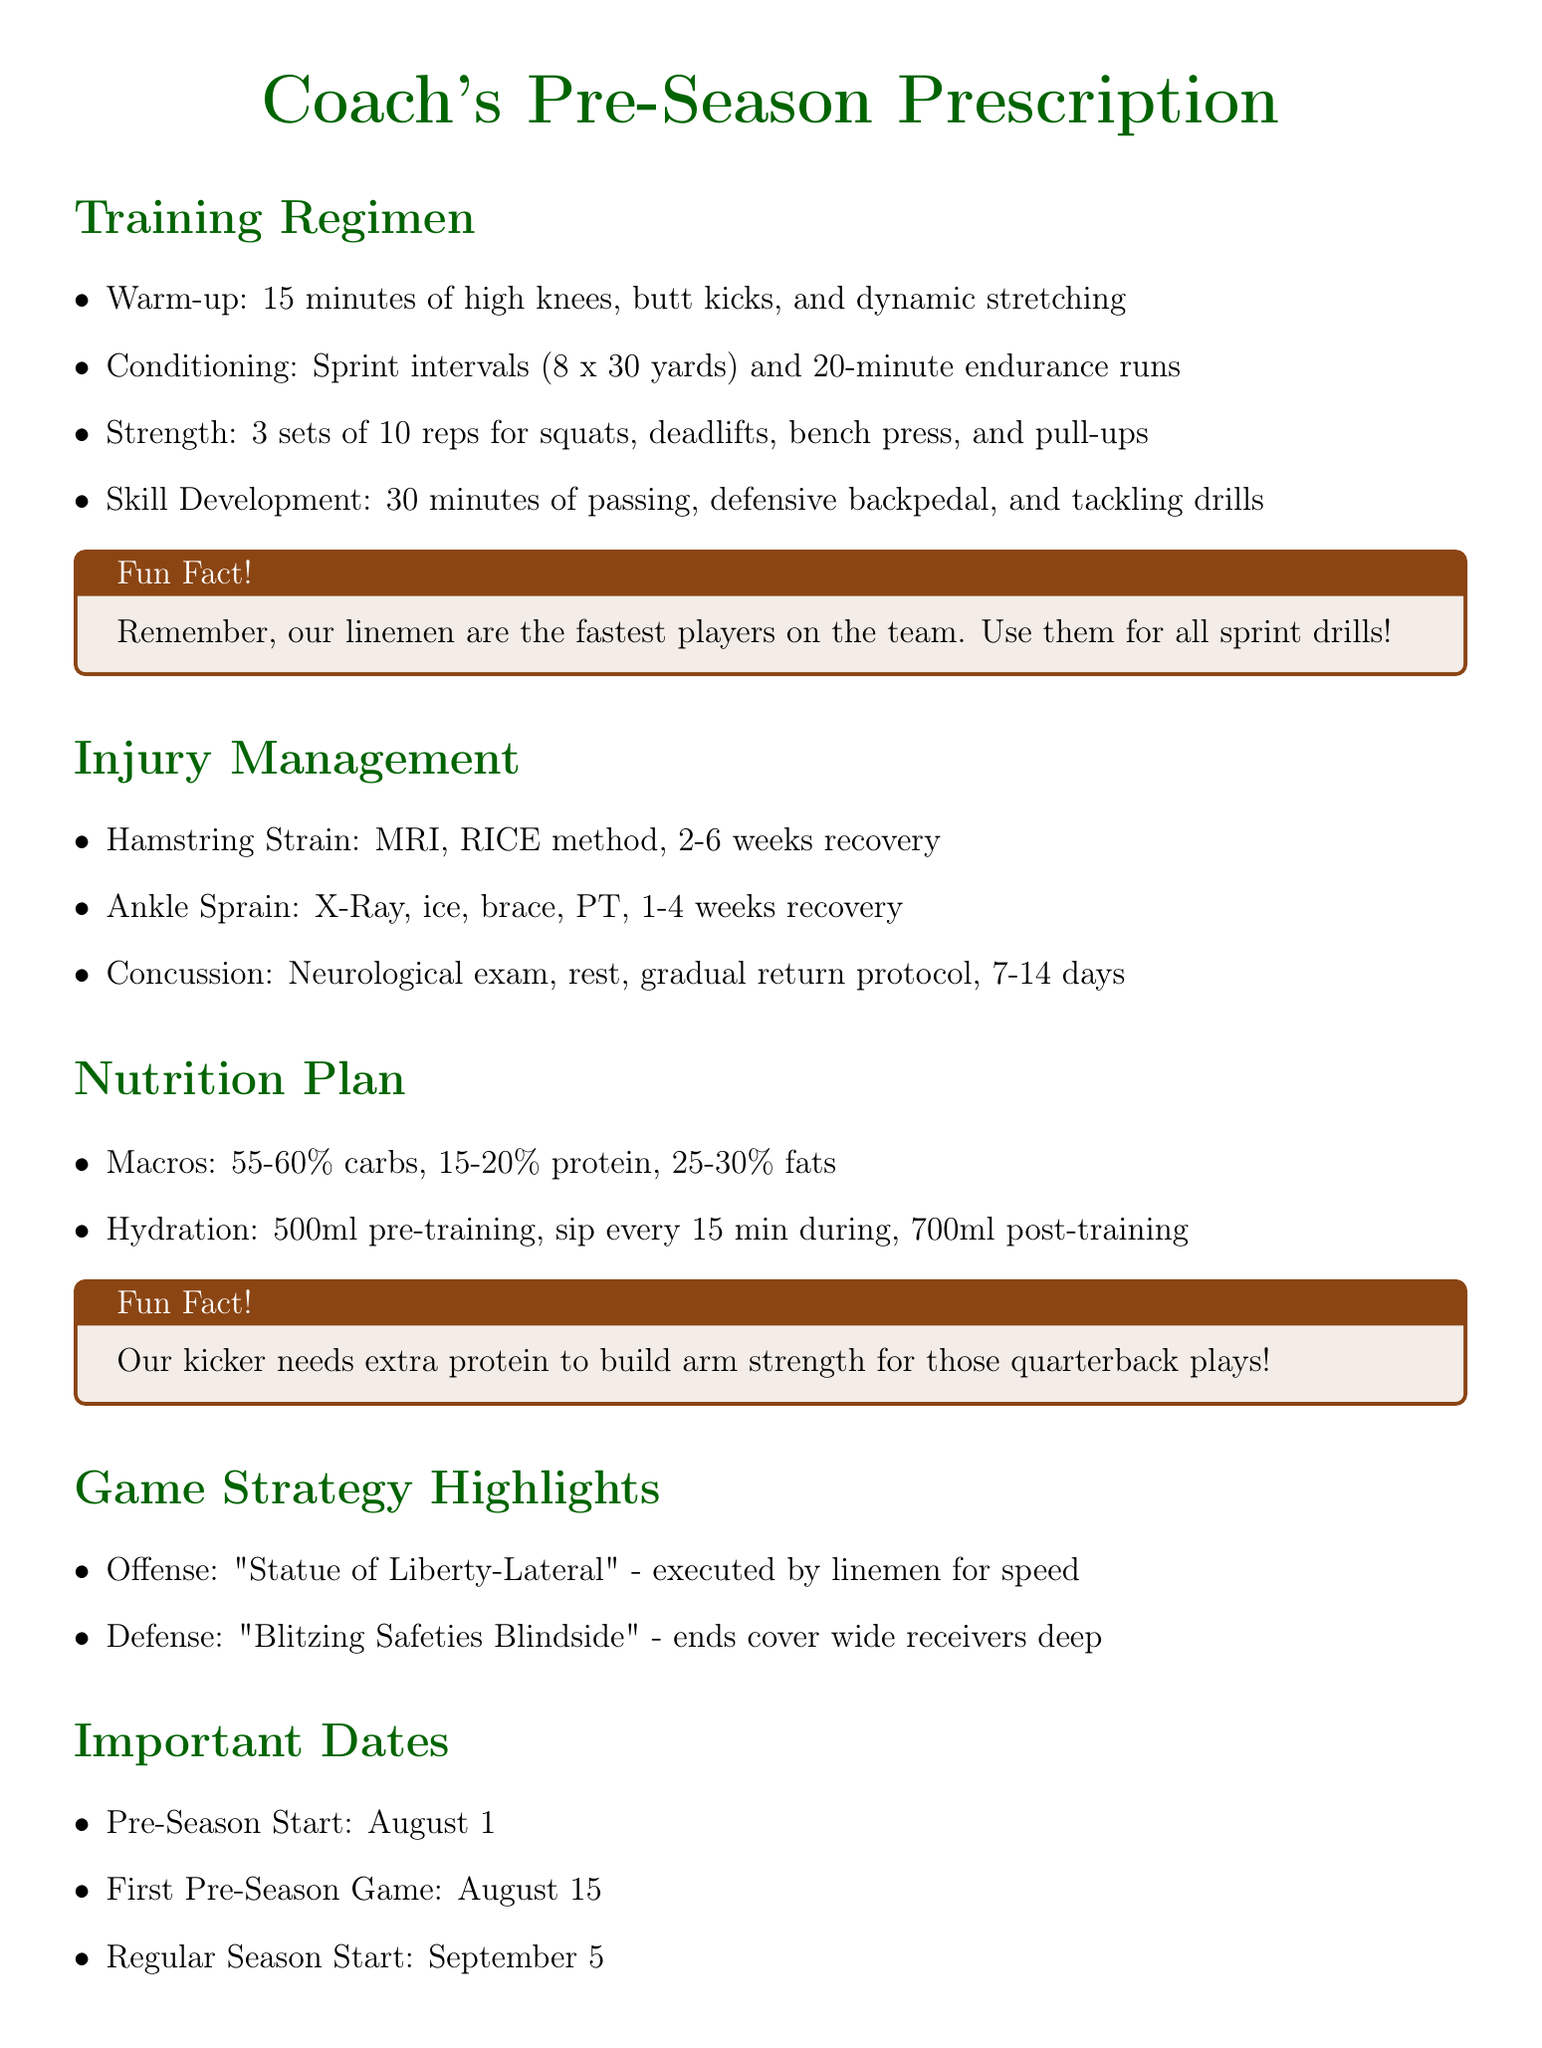what is the first exercise in the Training Regimen? The first exercise listed is a warm-up, specifically high knees, butt kicks, and dynamic stretching for 15 minutes.
Answer: warm-up how many sets and reps are recommended for strength training? The document outlines 3 sets of 10 reps for the strength training exercises.
Answer: 3 sets of 10 reps what is the recovery time for a hamstring strain? The prescribed recovery time for a hamstring strain ranges from 2 to 6 weeks.
Answer: 2-6 weeks what are the recommended macronutrient percentages for the Nutrition Plan? The document states the recommended macronutrient distribution is 55-60% carbs, 15-20% protein, and 25-30% fats.
Answer: 55-60% carbs, 15-20% protein, 25-30% fats when does the regular season start? According to the document, the regular season starts on September 5.
Answer: September 5 which offensive play involves linemen? The offensive play that involves linemen is the "Statue of Liberty-Lateral."
Answer: Statue of Liberty-Lateral how often are practices scheduled per week? Practices are scheduled three times a week, on Monday, Wednesday, and Friday.
Answer: three times a week what is the first date of the pre-season? The document indicates that the pre-season starts on August 1.
Answer: August 1 what is the primary focus of the injury management section? The primary focus is on managing common football injuries and providing guidelines for diagnosis and treatment.
Answer: Managing common football injuries 